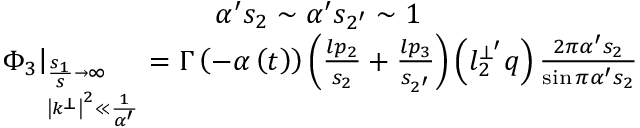<formula> <loc_0><loc_0><loc_500><loc_500>\begin{array} { c } { { \alpha ^ { \prime } s _ { 2 } \sim \alpha ^ { \prime } s _ { 2 ^ { \prime } } \sim 1 } } \\ { { \Phi _ { 3 } \right | _ { _ { \left | k ^ { \bot } \right | ^ { 2 } \ll \frac { 1 } \alpha ^ { \prime } } } ^ { \frac { s _ { 1 } } s \rightarrow \infty } } = \Gamma \left ( - \alpha \left ( t \right ) \right ) \left ( \frac { l p _ { 2 } } { s _ { 2 } } + \frac { l p _ { 3 } } { s _ { 2 ^ { \prime } } } \right ) \left ( l _ { 2 } ^ { \bot ^ { \prime } } q \right ) \frac { 2 \pi \alpha ^ { \prime } s _ { 2 } } { \sin \pi \alpha ^ { \prime } s _ { 2 } } } } \end{array}</formula> 